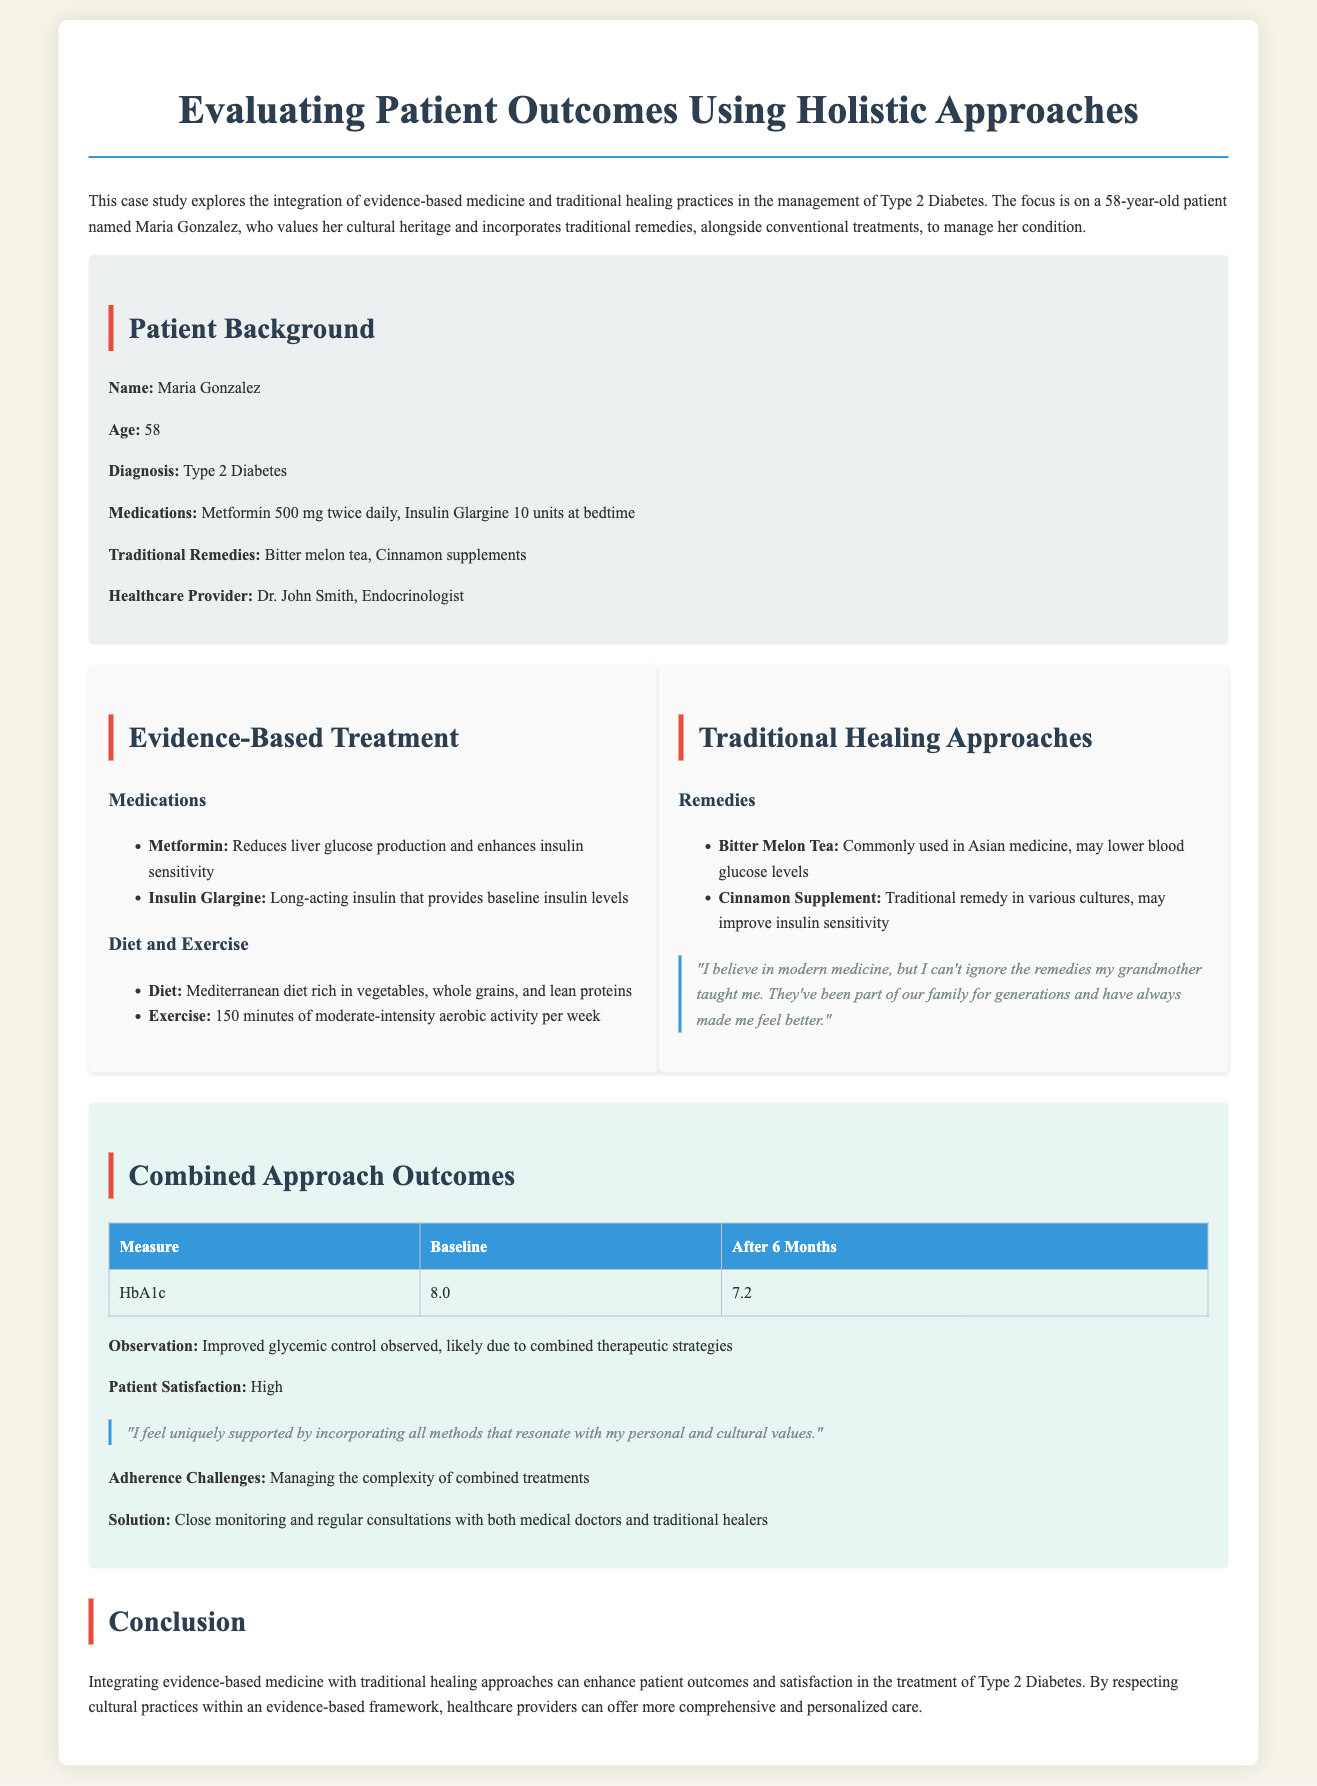What is the patient's name? The document states the patient's name as Maria Gonzalez.
Answer: Maria Gonzalez How old is Maria Gonzalez? The document specifies Maria Gonzalez's age as 58.
Answer: 58 What medications is Maria taking? The document lists Metformin and Insulin Glargine as the medications Maria is taking.
Answer: Metformin 500 mg twice daily, Insulin Glargine 10 units at bedtime What traditional remedy is mentioned first? The document notes Bitter melon tea as the first traditional remedy.
Answer: Bitter melon tea What was Maria's HbA1c level at baseline? The document reports the baseline HbA1c level as 8.0.
Answer: 8.0 What is the primary diet recommended for Maria? The document describes the Mediterranean diet as the recommended primary diet.
Answer: Mediterranean diet What was the HbA1c level after 6 months? The document indicates the HbA1c level after 6 months was 7.2.
Answer: 7.2 What was the observation regarding glycemic control? The document states that improved glycemic control was observed.
Answer: Improved glycemic control Who is Maria’s healthcare provider? The document identifies Dr. John Smith as Maria's healthcare provider.
Answer: Dr. John Smith What were the adherence challenges mentioned? The document specifies managing the complexity of combined treatments as the adherence challenge.
Answer: Managing the complexity of combined treatments 